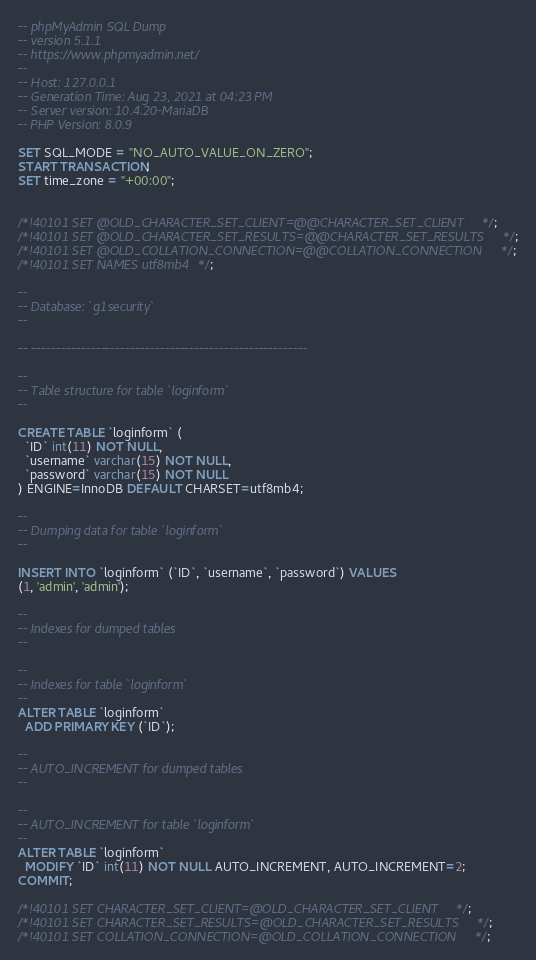Convert code to text. <code><loc_0><loc_0><loc_500><loc_500><_SQL_>-- phpMyAdmin SQL Dump
-- version 5.1.1
-- https://www.phpmyadmin.net/
--
-- Host: 127.0.0.1
-- Generation Time: Aug 23, 2021 at 04:23 PM
-- Server version: 10.4.20-MariaDB
-- PHP Version: 8.0.9

SET SQL_MODE = "NO_AUTO_VALUE_ON_ZERO";
START TRANSACTION;
SET time_zone = "+00:00";


/*!40101 SET @OLD_CHARACTER_SET_CLIENT=@@CHARACTER_SET_CLIENT */;
/*!40101 SET @OLD_CHARACTER_SET_RESULTS=@@CHARACTER_SET_RESULTS */;
/*!40101 SET @OLD_COLLATION_CONNECTION=@@COLLATION_CONNECTION */;
/*!40101 SET NAMES utf8mb4 */;

--
-- Database: `g1security`
--

-- --------------------------------------------------------

--
-- Table structure for table `loginform`
--

CREATE TABLE `loginform` (
  `ID` int(11) NOT NULL,
  `username` varchar(15) NOT NULL,
  `password` varchar(15) NOT NULL
) ENGINE=InnoDB DEFAULT CHARSET=utf8mb4;

--
-- Dumping data for table `loginform`
--

INSERT INTO `loginform` (`ID`, `username`, `password`) VALUES
(1, 'admin', 'admin');

--
-- Indexes for dumped tables
--

--
-- Indexes for table `loginform`
--
ALTER TABLE `loginform`
  ADD PRIMARY KEY (`ID`);

--
-- AUTO_INCREMENT for dumped tables
--

--
-- AUTO_INCREMENT for table `loginform`
--
ALTER TABLE `loginform`
  MODIFY `ID` int(11) NOT NULL AUTO_INCREMENT, AUTO_INCREMENT=2;
COMMIT;

/*!40101 SET CHARACTER_SET_CLIENT=@OLD_CHARACTER_SET_CLIENT */;
/*!40101 SET CHARACTER_SET_RESULTS=@OLD_CHARACTER_SET_RESULTS */;
/*!40101 SET COLLATION_CONNECTION=@OLD_COLLATION_CONNECTION */;
</code> 